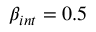Convert formula to latex. <formula><loc_0><loc_0><loc_500><loc_500>\beta _ { i n t } = 0 . 5</formula> 